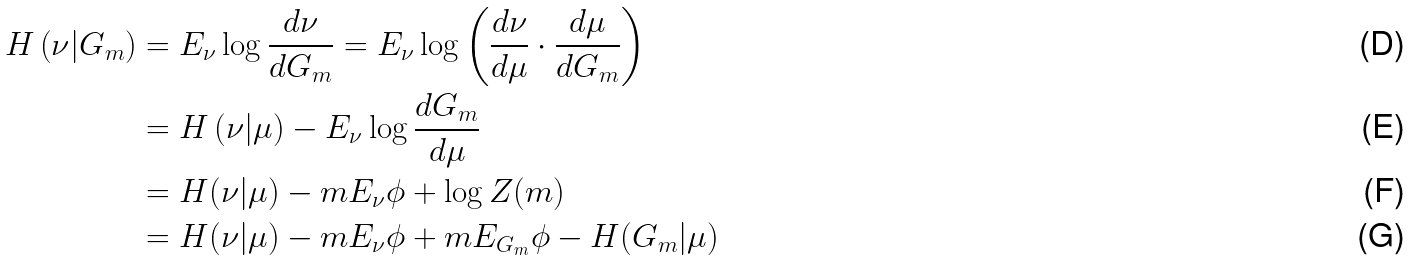Convert formula to latex. <formula><loc_0><loc_0><loc_500><loc_500>H \left ( \nu | G _ { m } \right ) & = E _ { \nu } \log { \frac { d \nu } { d G _ { m } } } = { E } _ { \nu } \log \left ( { \frac { d \nu } { d \mu } } \cdot { \frac { d \mu } { d G _ { m } } } \right ) \\ & = H \left ( \nu | \mu \right ) - E _ { \nu } \log { \frac { d G _ { m } } { d \mu } } \\ & = H ( \nu | \mu ) - m E _ { \nu } \phi + \log Z ( m ) \\ & = H ( \nu | \mu ) - m E _ { \nu } \phi + m E _ { G _ { m } } \phi - H ( G _ { m } | \mu )</formula> 